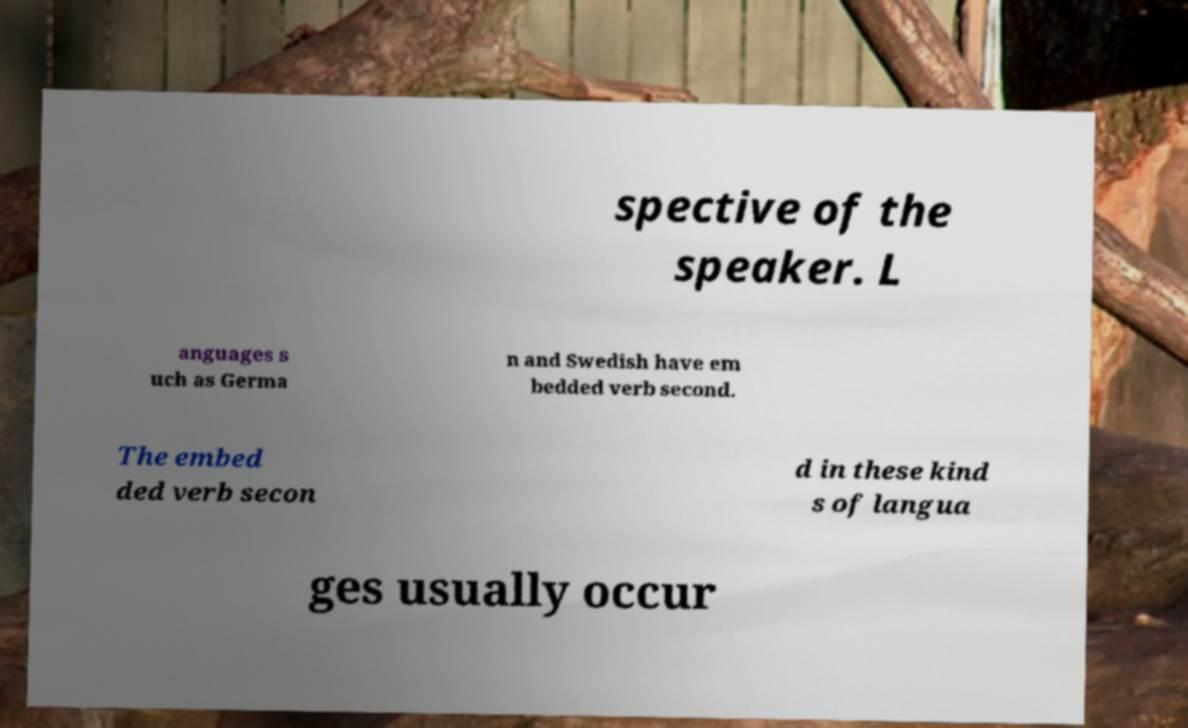Can you read and provide the text displayed in the image?This photo seems to have some interesting text. Can you extract and type it out for me? spective of the speaker. L anguages s uch as Germa n and Swedish have em bedded verb second. The embed ded verb secon d in these kind s of langua ges usually occur 